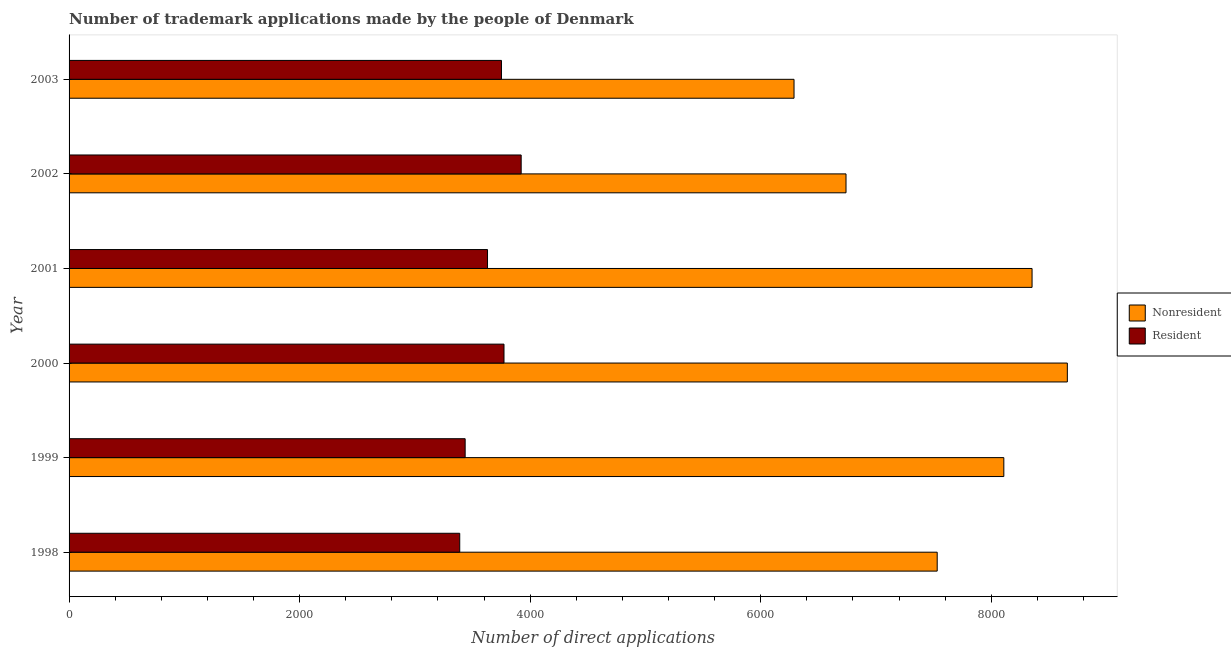How many different coloured bars are there?
Your answer should be compact. 2. How many groups of bars are there?
Provide a succinct answer. 6. How many bars are there on the 4th tick from the top?
Your response must be concise. 2. What is the label of the 4th group of bars from the top?
Make the answer very short. 2000. In how many cases, is the number of bars for a given year not equal to the number of legend labels?
Keep it short and to the point. 0. What is the number of trademark applications made by residents in 1998?
Provide a short and direct response. 3389. Across all years, what is the maximum number of trademark applications made by residents?
Offer a terse response. 3922. Across all years, what is the minimum number of trademark applications made by residents?
Your answer should be very brief. 3389. In which year was the number of trademark applications made by non residents maximum?
Ensure brevity in your answer.  2000. What is the total number of trademark applications made by residents in the graph?
Keep it short and to the point. 2.19e+04. What is the difference between the number of trademark applications made by residents in 2000 and that in 2001?
Ensure brevity in your answer.  143. What is the difference between the number of trademark applications made by residents in 2001 and the number of trademark applications made by non residents in 2003?
Make the answer very short. -2659. What is the average number of trademark applications made by non residents per year?
Your answer should be very brief. 7613.83. In the year 1999, what is the difference between the number of trademark applications made by residents and number of trademark applications made by non residents?
Your answer should be compact. -4673. In how many years, is the number of trademark applications made by residents greater than 3600 ?
Keep it short and to the point. 4. What is the ratio of the number of trademark applications made by non residents in 1998 to that in 2003?
Your answer should be compact. 1.2. Is the number of trademark applications made by residents in 1998 less than that in 2001?
Your response must be concise. Yes. Is the difference between the number of trademark applications made by residents in 2002 and 2003 greater than the difference between the number of trademark applications made by non residents in 2002 and 2003?
Your response must be concise. No. What is the difference between the highest and the second highest number of trademark applications made by non residents?
Your answer should be very brief. 306. What is the difference between the highest and the lowest number of trademark applications made by non residents?
Your answer should be very brief. 2371. In how many years, is the number of trademark applications made by non residents greater than the average number of trademark applications made by non residents taken over all years?
Make the answer very short. 3. What does the 1st bar from the top in 2003 represents?
Keep it short and to the point. Resident. What does the 1st bar from the bottom in 2003 represents?
Your answer should be compact. Nonresident. How many bars are there?
Provide a short and direct response. 12. How many years are there in the graph?
Make the answer very short. 6. Where does the legend appear in the graph?
Offer a terse response. Center right. What is the title of the graph?
Your response must be concise. Number of trademark applications made by the people of Denmark. What is the label or title of the X-axis?
Make the answer very short. Number of direct applications. What is the label or title of the Y-axis?
Offer a very short reply. Year. What is the Number of direct applications in Nonresident in 1998?
Your response must be concise. 7531. What is the Number of direct applications in Resident in 1998?
Provide a short and direct response. 3389. What is the Number of direct applications in Nonresident in 1999?
Provide a succinct answer. 8109. What is the Number of direct applications in Resident in 1999?
Keep it short and to the point. 3436. What is the Number of direct applications in Nonresident in 2000?
Provide a short and direct response. 8660. What is the Number of direct applications in Resident in 2000?
Offer a very short reply. 3773. What is the Number of direct applications in Nonresident in 2001?
Your response must be concise. 8354. What is the Number of direct applications in Resident in 2001?
Provide a short and direct response. 3630. What is the Number of direct applications of Nonresident in 2002?
Make the answer very short. 6740. What is the Number of direct applications of Resident in 2002?
Offer a very short reply. 3922. What is the Number of direct applications of Nonresident in 2003?
Make the answer very short. 6289. What is the Number of direct applications in Resident in 2003?
Offer a very short reply. 3751. Across all years, what is the maximum Number of direct applications in Nonresident?
Provide a succinct answer. 8660. Across all years, what is the maximum Number of direct applications in Resident?
Provide a succinct answer. 3922. Across all years, what is the minimum Number of direct applications of Nonresident?
Your answer should be compact. 6289. Across all years, what is the minimum Number of direct applications in Resident?
Your answer should be compact. 3389. What is the total Number of direct applications in Nonresident in the graph?
Offer a terse response. 4.57e+04. What is the total Number of direct applications in Resident in the graph?
Offer a terse response. 2.19e+04. What is the difference between the Number of direct applications of Nonresident in 1998 and that in 1999?
Offer a very short reply. -578. What is the difference between the Number of direct applications in Resident in 1998 and that in 1999?
Make the answer very short. -47. What is the difference between the Number of direct applications of Nonresident in 1998 and that in 2000?
Give a very brief answer. -1129. What is the difference between the Number of direct applications in Resident in 1998 and that in 2000?
Ensure brevity in your answer.  -384. What is the difference between the Number of direct applications of Nonresident in 1998 and that in 2001?
Keep it short and to the point. -823. What is the difference between the Number of direct applications of Resident in 1998 and that in 2001?
Offer a terse response. -241. What is the difference between the Number of direct applications of Nonresident in 1998 and that in 2002?
Ensure brevity in your answer.  791. What is the difference between the Number of direct applications in Resident in 1998 and that in 2002?
Make the answer very short. -533. What is the difference between the Number of direct applications of Nonresident in 1998 and that in 2003?
Make the answer very short. 1242. What is the difference between the Number of direct applications of Resident in 1998 and that in 2003?
Your response must be concise. -362. What is the difference between the Number of direct applications of Nonresident in 1999 and that in 2000?
Your answer should be very brief. -551. What is the difference between the Number of direct applications in Resident in 1999 and that in 2000?
Ensure brevity in your answer.  -337. What is the difference between the Number of direct applications in Nonresident in 1999 and that in 2001?
Make the answer very short. -245. What is the difference between the Number of direct applications in Resident in 1999 and that in 2001?
Your answer should be compact. -194. What is the difference between the Number of direct applications of Nonresident in 1999 and that in 2002?
Provide a short and direct response. 1369. What is the difference between the Number of direct applications in Resident in 1999 and that in 2002?
Offer a terse response. -486. What is the difference between the Number of direct applications of Nonresident in 1999 and that in 2003?
Your answer should be very brief. 1820. What is the difference between the Number of direct applications in Resident in 1999 and that in 2003?
Provide a succinct answer. -315. What is the difference between the Number of direct applications of Nonresident in 2000 and that in 2001?
Ensure brevity in your answer.  306. What is the difference between the Number of direct applications in Resident in 2000 and that in 2001?
Your response must be concise. 143. What is the difference between the Number of direct applications of Nonresident in 2000 and that in 2002?
Offer a very short reply. 1920. What is the difference between the Number of direct applications of Resident in 2000 and that in 2002?
Your answer should be very brief. -149. What is the difference between the Number of direct applications of Nonresident in 2000 and that in 2003?
Ensure brevity in your answer.  2371. What is the difference between the Number of direct applications of Resident in 2000 and that in 2003?
Give a very brief answer. 22. What is the difference between the Number of direct applications of Nonresident in 2001 and that in 2002?
Keep it short and to the point. 1614. What is the difference between the Number of direct applications of Resident in 2001 and that in 2002?
Offer a terse response. -292. What is the difference between the Number of direct applications in Nonresident in 2001 and that in 2003?
Keep it short and to the point. 2065. What is the difference between the Number of direct applications of Resident in 2001 and that in 2003?
Ensure brevity in your answer.  -121. What is the difference between the Number of direct applications of Nonresident in 2002 and that in 2003?
Your response must be concise. 451. What is the difference between the Number of direct applications in Resident in 2002 and that in 2003?
Your answer should be very brief. 171. What is the difference between the Number of direct applications of Nonresident in 1998 and the Number of direct applications of Resident in 1999?
Provide a succinct answer. 4095. What is the difference between the Number of direct applications of Nonresident in 1998 and the Number of direct applications of Resident in 2000?
Keep it short and to the point. 3758. What is the difference between the Number of direct applications in Nonresident in 1998 and the Number of direct applications in Resident in 2001?
Keep it short and to the point. 3901. What is the difference between the Number of direct applications in Nonresident in 1998 and the Number of direct applications in Resident in 2002?
Give a very brief answer. 3609. What is the difference between the Number of direct applications of Nonresident in 1998 and the Number of direct applications of Resident in 2003?
Give a very brief answer. 3780. What is the difference between the Number of direct applications in Nonresident in 1999 and the Number of direct applications in Resident in 2000?
Offer a terse response. 4336. What is the difference between the Number of direct applications in Nonresident in 1999 and the Number of direct applications in Resident in 2001?
Offer a very short reply. 4479. What is the difference between the Number of direct applications in Nonresident in 1999 and the Number of direct applications in Resident in 2002?
Make the answer very short. 4187. What is the difference between the Number of direct applications of Nonresident in 1999 and the Number of direct applications of Resident in 2003?
Offer a terse response. 4358. What is the difference between the Number of direct applications of Nonresident in 2000 and the Number of direct applications of Resident in 2001?
Ensure brevity in your answer.  5030. What is the difference between the Number of direct applications of Nonresident in 2000 and the Number of direct applications of Resident in 2002?
Your response must be concise. 4738. What is the difference between the Number of direct applications in Nonresident in 2000 and the Number of direct applications in Resident in 2003?
Your answer should be very brief. 4909. What is the difference between the Number of direct applications of Nonresident in 2001 and the Number of direct applications of Resident in 2002?
Give a very brief answer. 4432. What is the difference between the Number of direct applications in Nonresident in 2001 and the Number of direct applications in Resident in 2003?
Make the answer very short. 4603. What is the difference between the Number of direct applications of Nonresident in 2002 and the Number of direct applications of Resident in 2003?
Provide a succinct answer. 2989. What is the average Number of direct applications in Nonresident per year?
Your response must be concise. 7613.83. What is the average Number of direct applications of Resident per year?
Give a very brief answer. 3650.17. In the year 1998, what is the difference between the Number of direct applications in Nonresident and Number of direct applications in Resident?
Your answer should be very brief. 4142. In the year 1999, what is the difference between the Number of direct applications of Nonresident and Number of direct applications of Resident?
Ensure brevity in your answer.  4673. In the year 2000, what is the difference between the Number of direct applications in Nonresident and Number of direct applications in Resident?
Provide a short and direct response. 4887. In the year 2001, what is the difference between the Number of direct applications of Nonresident and Number of direct applications of Resident?
Ensure brevity in your answer.  4724. In the year 2002, what is the difference between the Number of direct applications of Nonresident and Number of direct applications of Resident?
Your answer should be very brief. 2818. In the year 2003, what is the difference between the Number of direct applications of Nonresident and Number of direct applications of Resident?
Provide a short and direct response. 2538. What is the ratio of the Number of direct applications in Nonresident in 1998 to that in 1999?
Make the answer very short. 0.93. What is the ratio of the Number of direct applications of Resident in 1998 to that in 1999?
Provide a short and direct response. 0.99. What is the ratio of the Number of direct applications of Nonresident in 1998 to that in 2000?
Offer a very short reply. 0.87. What is the ratio of the Number of direct applications in Resident in 1998 to that in 2000?
Your answer should be compact. 0.9. What is the ratio of the Number of direct applications of Nonresident in 1998 to that in 2001?
Keep it short and to the point. 0.9. What is the ratio of the Number of direct applications in Resident in 1998 to that in 2001?
Ensure brevity in your answer.  0.93. What is the ratio of the Number of direct applications of Nonresident in 1998 to that in 2002?
Ensure brevity in your answer.  1.12. What is the ratio of the Number of direct applications in Resident in 1998 to that in 2002?
Give a very brief answer. 0.86. What is the ratio of the Number of direct applications in Nonresident in 1998 to that in 2003?
Offer a very short reply. 1.2. What is the ratio of the Number of direct applications of Resident in 1998 to that in 2003?
Your answer should be compact. 0.9. What is the ratio of the Number of direct applications in Nonresident in 1999 to that in 2000?
Your response must be concise. 0.94. What is the ratio of the Number of direct applications of Resident in 1999 to that in 2000?
Your response must be concise. 0.91. What is the ratio of the Number of direct applications of Nonresident in 1999 to that in 2001?
Your answer should be compact. 0.97. What is the ratio of the Number of direct applications of Resident in 1999 to that in 2001?
Offer a terse response. 0.95. What is the ratio of the Number of direct applications in Nonresident in 1999 to that in 2002?
Keep it short and to the point. 1.2. What is the ratio of the Number of direct applications in Resident in 1999 to that in 2002?
Offer a terse response. 0.88. What is the ratio of the Number of direct applications of Nonresident in 1999 to that in 2003?
Make the answer very short. 1.29. What is the ratio of the Number of direct applications in Resident in 1999 to that in 2003?
Provide a succinct answer. 0.92. What is the ratio of the Number of direct applications of Nonresident in 2000 to that in 2001?
Make the answer very short. 1.04. What is the ratio of the Number of direct applications in Resident in 2000 to that in 2001?
Offer a terse response. 1.04. What is the ratio of the Number of direct applications in Nonresident in 2000 to that in 2002?
Provide a succinct answer. 1.28. What is the ratio of the Number of direct applications in Nonresident in 2000 to that in 2003?
Give a very brief answer. 1.38. What is the ratio of the Number of direct applications of Resident in 2000 to that in 2003?
Offer a terse response. 1.01. What is the ratio of the Number of direct applications in Nonresident in 2001 to that in 2002?
Your answer should be very brief. 1.24. What is the ratio of the Number of direct applications of Resident in 2001 to that in 2002?
Your answer should be compact. 0.93. What is the ratio of the Number of direct applications of Nonresident in 2001 to that in 2003?
Your response must be concise. 1.33. What is the ratio of the Number of direct applications in Resident in 2001 to that in 2003?
Provide a succinct answer. 0.97. What is the ratio of the Number of direct applications of Nonresident in 2002 to that in 2003?
Give a very brief answer. 1.07. What is the ratio of the Number of direct applications in Resident in 2002 to that in 2003?
Your response must be concise. 1.05. What is the difference between the highest and the second highest Number of direct applications in Nonresident?
Provide a short and direct response. 306. What is the difference between the highest and the second highest Number of direct applications of Resident?
Give a very brief answer. 149. What is the difference between the highest and the lowest Number of direct applications in Nonresident?
Give a very brief answer. 2371. What is the difference between the highest and the lowest Number of direct applications in Resident?
Offer a terse response. 533. 